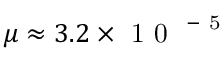Convert formula to latex. <formula><loc_0><loc_0><loc_500><loc_500>\mu \approx 3 . 2 \times 1 0 ^ { - 5 }</formula> 